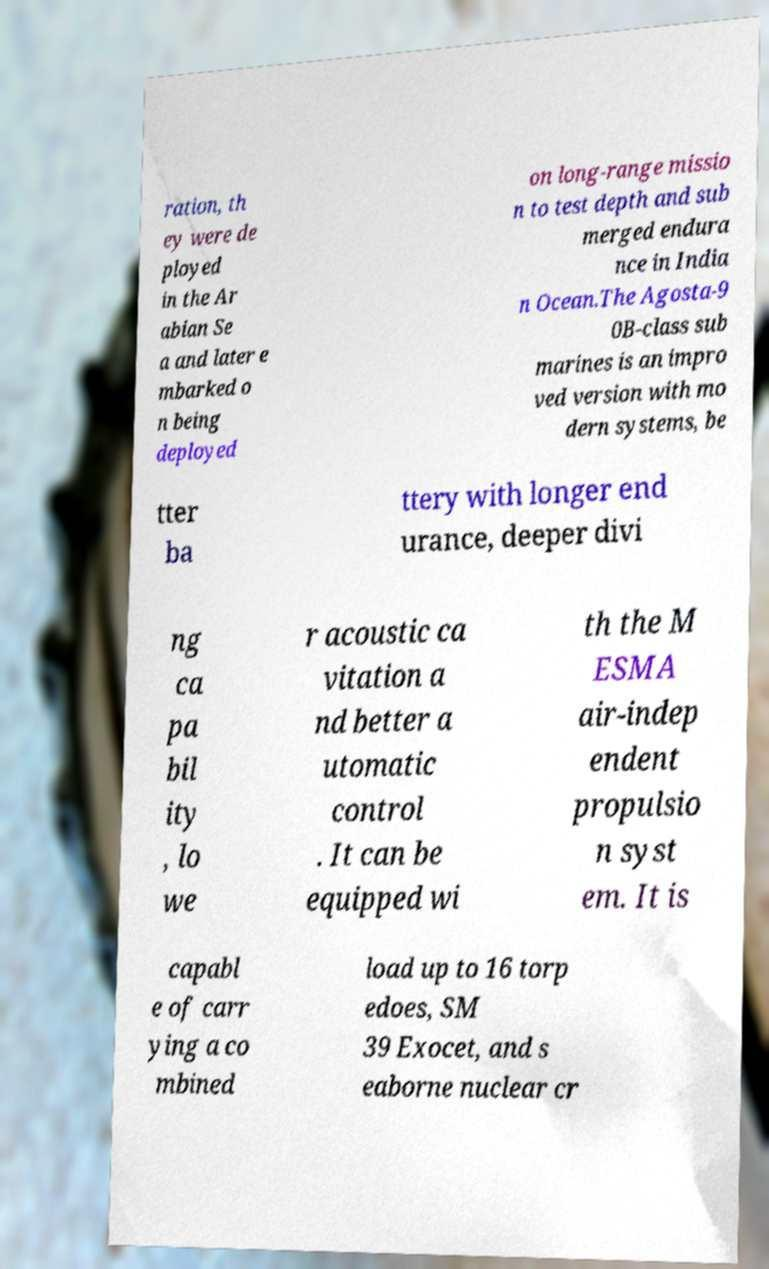What messages or text are displayed in this image? I need them in a readable, typed format. ration, th ey were de ployed in the Ar abian Se a and later e mbarked o n being deployed on long-range missio n to test depth and sub merged endura nce in India n Ocean.The Agosta-9 0B-class sub marines is an impro ved version with mo dern systems, be tter ba ttery with longer end urance, deeper divi ng ca pa bil ity , lo we r acoustic ca vitation a nd better a utomatic control . It can be equipped wi th the M ESMA air-indep endent propulsio n syst em. It is capabl e of carr ying a co mbined load up to 16 torp edoes, SM 39 Exocet, and s eaborne nuclear cr 